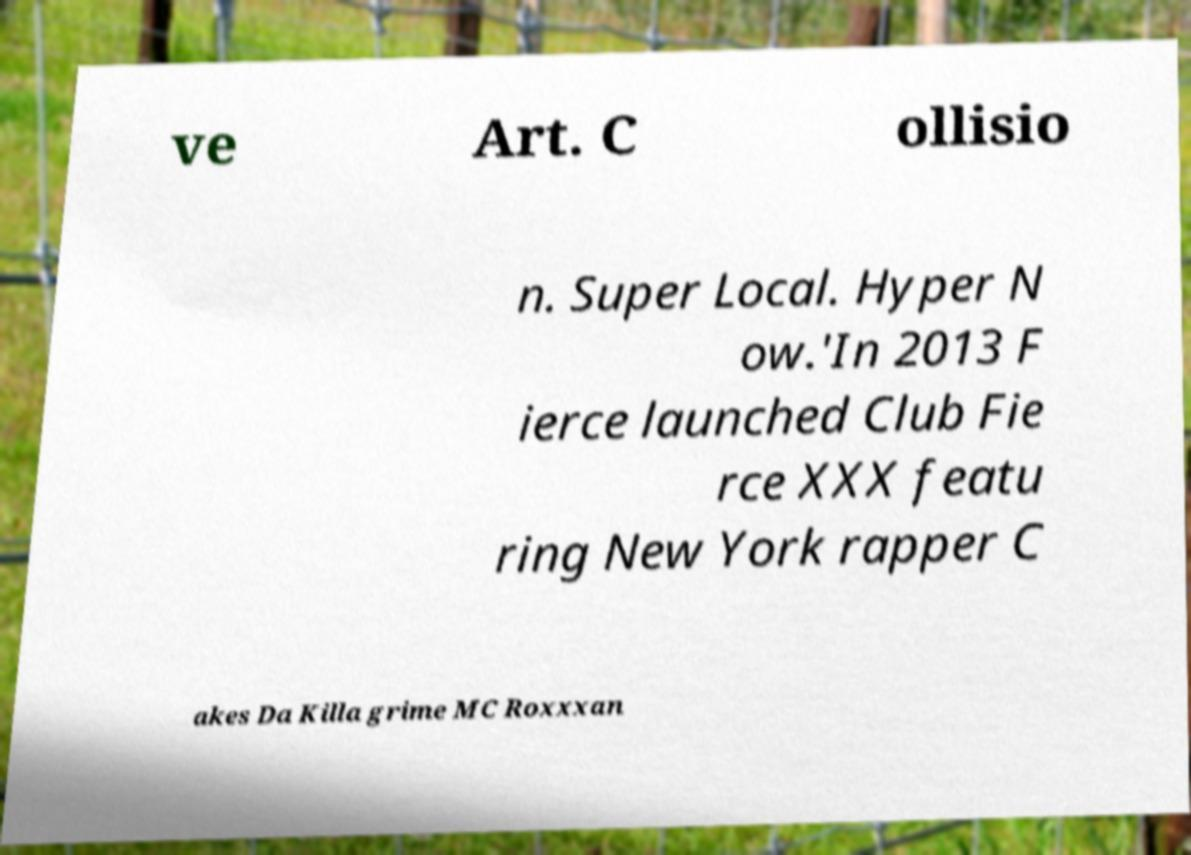Please identify and transcribe the text found in this image. ve Art. C ollisio n. Super Local. Hyper N ow.'In 2013 F ierce launched Club Fie rce XXX featu ring New York rapper C akes Da Killa grime MC Roxxxan 